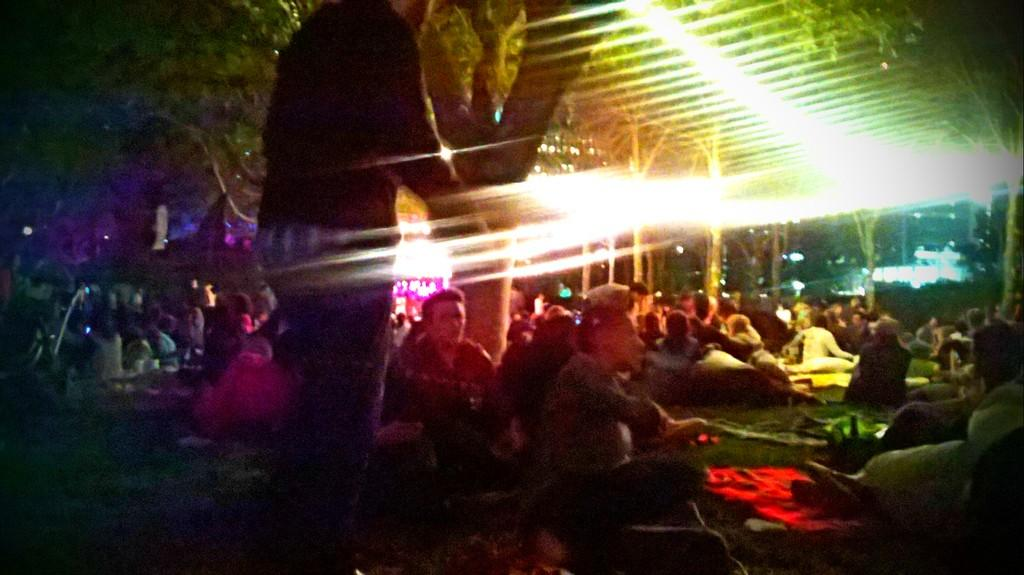What are the people in the image doing? There is a group of people sitting in the image. How can you describe the clothing of the people in the image? The people are wearing different color dresses. What can be seen in the background of the image? There are many trees and lights visible in the background. Can you describe the position of one person in the image? There is one person standing in the image. What type of toy can be seen in the hands of the person standing in the image? There is no toy visible in the image, as the person standing does not have any object in their hands. 